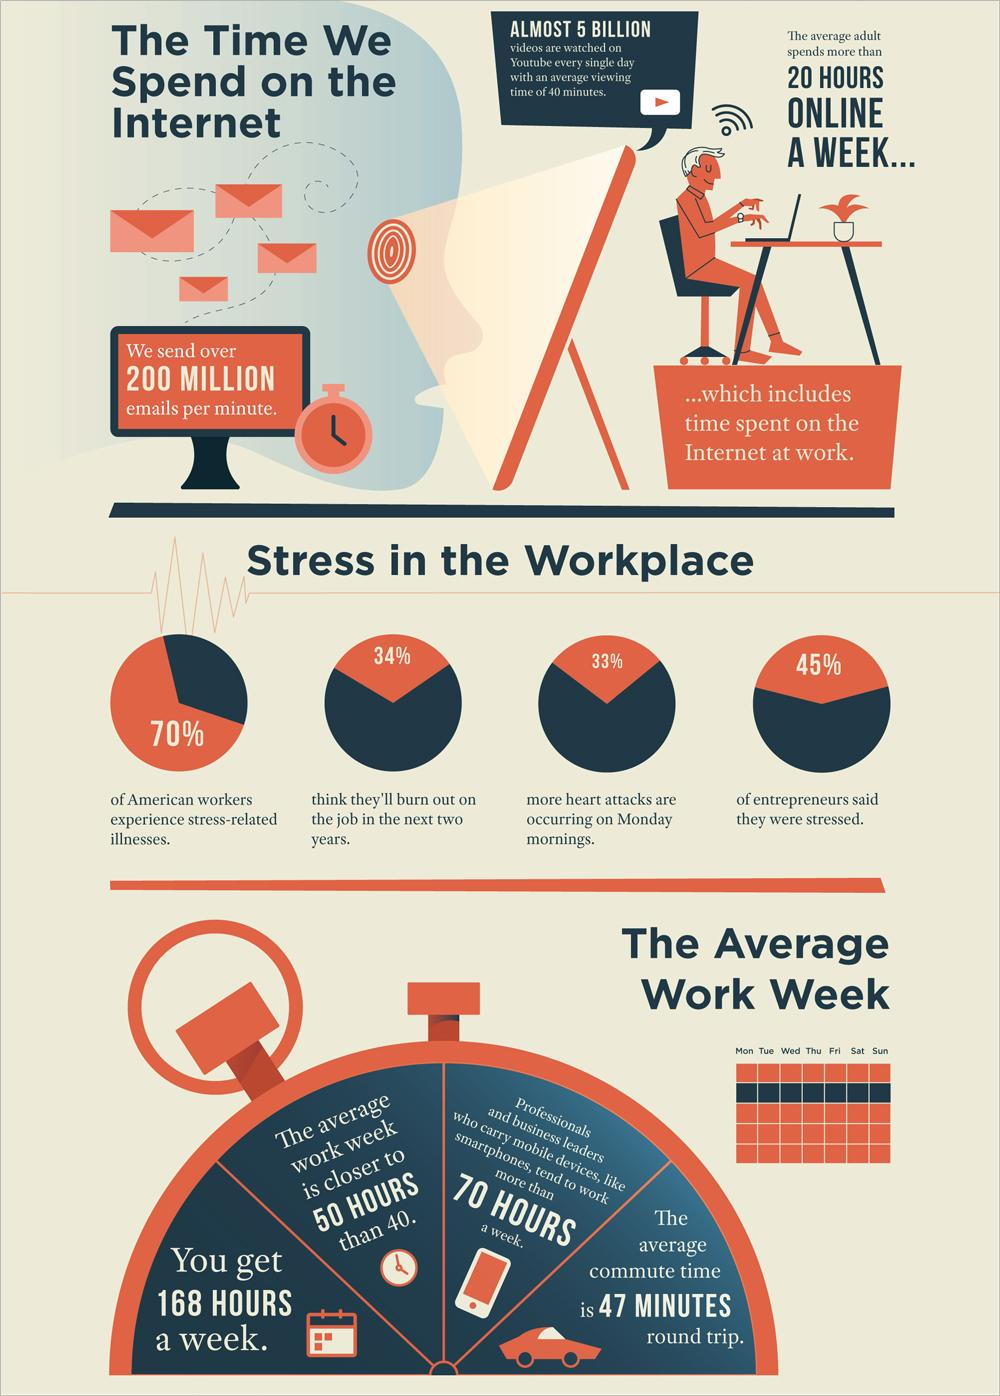List a handful of essential elements in this visual. Approximately 70% of American workers experience stress-related illnesses due to work-related stress. According to a survey of entrepreneurs, 45% of them reported feeling stressed. 